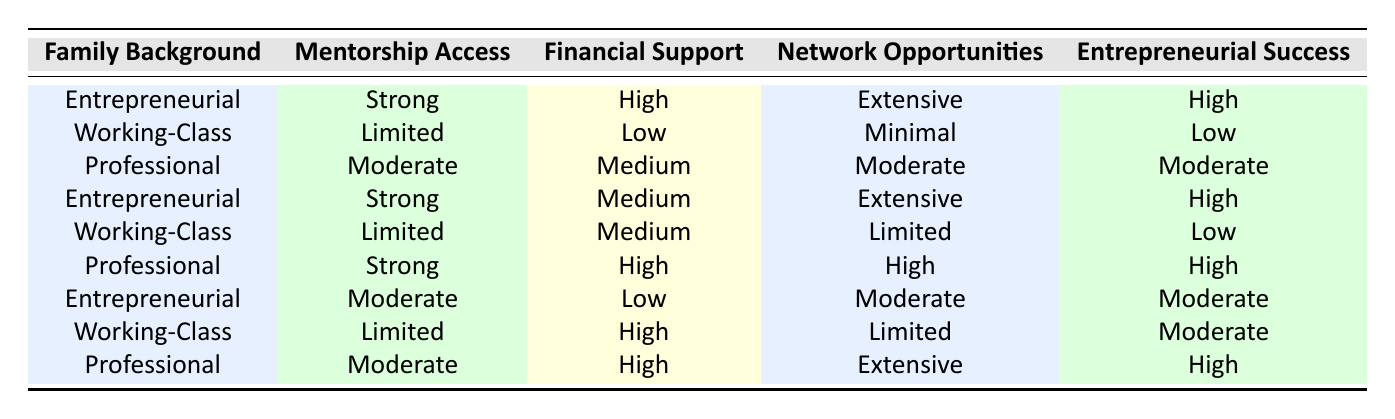What is the entrepreneurial success level for families with an entrepreneurial background and strong mentorship access? In the table, there are two instances of "Entrepreneurial" family background with "Strong" mentorship access. Both have "High" entrepreneurial success.
Answer: High What financial support do working-class families receive in combination with limited mentorship access? There are two instances of "Working-Class" with "Limited" mentorship access. One has "Low" financial support and the other has "Medium" financial support.
Answer: Low and Medium Is it true that families with a professional background and strong mentorship access have high entrepreneurial success? There is one instance of "Professional" background with "Strong" mentorship access that has "High" entrepreneurial success. Therefore, it is true.
Answer: Yes What is the average entrepreneurial success level for families from professional backgrounds? There are three data points with "Professional" backgrounds, yielding success levels of Moderate, High, and High. The total success levels add up to 2 (Moderate is treated as 1, High as 2), resulting in an average of (1 + 2 + 2) / 3 = 5 / 3 ≈ 1.67, which translates to moderate success.
Answer: Moderate For entrepreneurs with strong financial support, how many have high entrepreneurial success? In the table, there are three instances of strong financial support: one from a "Professional" family (High, High), and two with "Entrepreneurial" backgrounds (High, High). Therefore, all three show high success.
Answer: Three Are there any instances of working-class families attaining high entrepreneurial success? Looking through the "Working-Class" entries, none have achieved high success; they are either Low or Moderate.
Answer: No What combination leads to the highest entrepreneurial success according to the table? The combinations yielding "High" entrepreneurial success are: Entrepreneurial background with Strong mentorship and High financial support; Professional background with Strong mentorship, High financial support; Entrepreneurial background with Strong mentorship and Medium financial support. These all point to a strong link between family background, mentorship quality, and financial support.
Answer: Entrepreneurial with Strong mentorship and High financial support, Professional with Strong mentorship and High financial support How does the network opportunity influence level of success for working-class families with limited financial resources? In the table, working-class families with "Limited" and "Medium" financial support have "Low" success, while those with "High" financial support have "Moderate" success. This shows a direct correlation that higher network opportunities can enhance success, despite the limited resources.
Answer: Moderate 